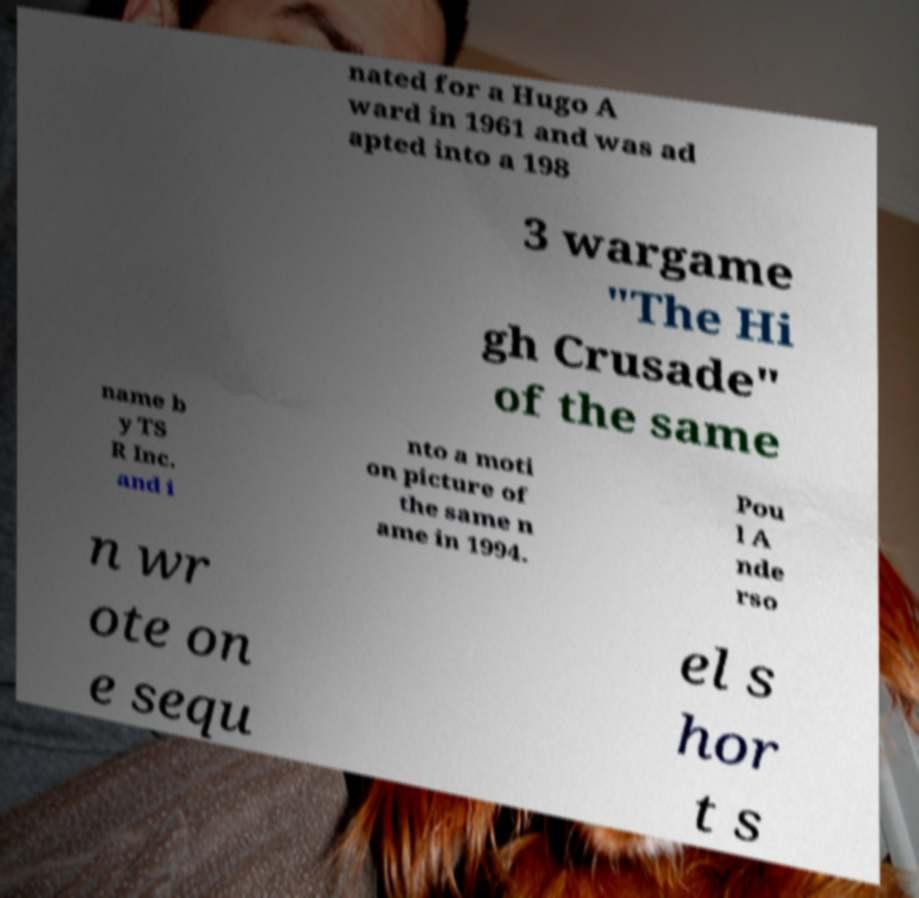Please identify and transcribe the text found in this image. nated for a Hugo A ward in 1961 and was ad apted into a 198 3 wargame "The Hi gh Crusade" of the same name b y TS R Inc. and i nto a moti on picture of the same n ame in 1994. Pou l A nde rso n wr ote on e sequ el s hor t s 